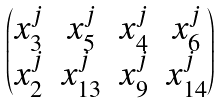<formula> <loc_0><loc_0><loc_500><loc_500>\begin{pmatrix} x _ { 3 } ^ { j } & x _ { 5 } ^ { j } & x _ { 4 } ^ { j } & x _ { 6 } ^ { j } \\ x _ { 2 } ^ { j } & x _ { 1 3 } ^ { j } & x _ { 9 } ^ { j } & x _ { 1 4 } ^ { j } \end{pmatrix}</formula> 